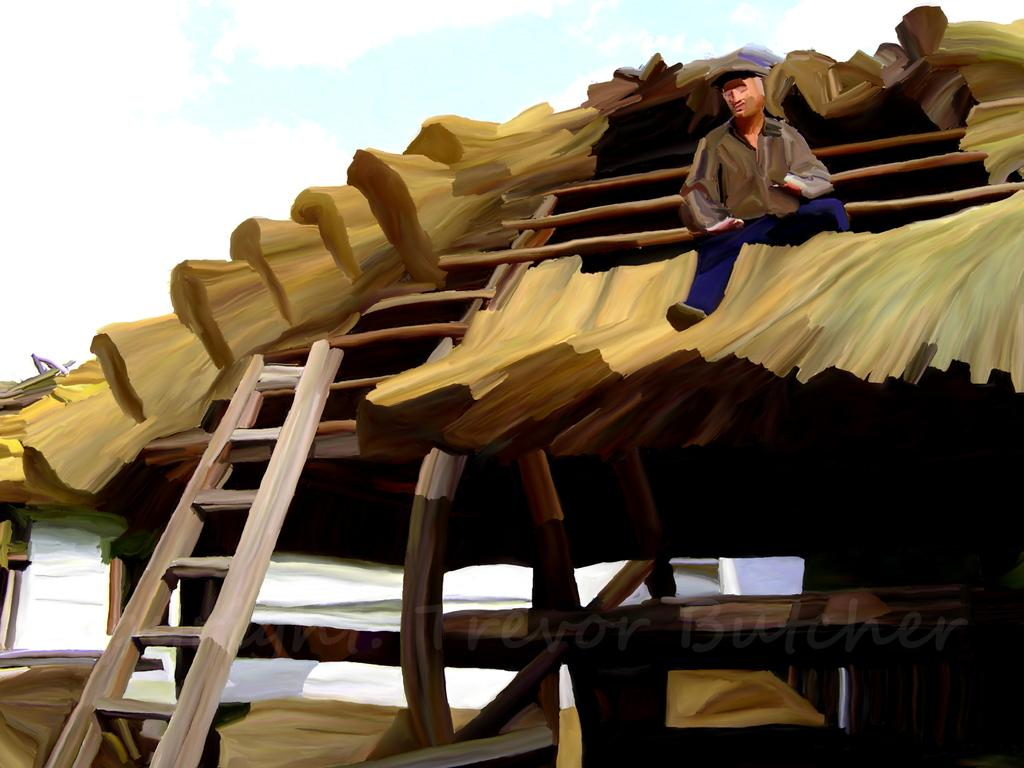What type of artwork is depicted in the image? The image is a painting. What is the man in the painting doing? The man is sitting on the rooftop in the painting. What object is present in the painting that might be used for climbing? There is a ladder in the painting. What can be seen in the background of the painting? The sky is visible behind the person in the painting. How does the man in the painting trick the birds into flying away? There are no birds present in the painting, and the man is not depicted as performing any actions to trick them. 